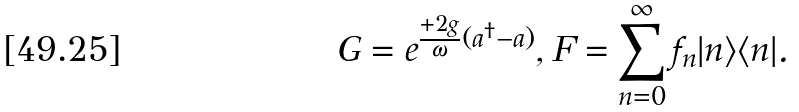Convert formula to latex. <formula><loc_0><loc_0><loc_500><loc_500>G = e ^ { \frac { + 2 g } { \omega } ( a ^ { \dag } - a ) } , F = \sum _ { n = 0 } ^ { \infty } f _ { n } | n \rangle \langle n | .</formula> 